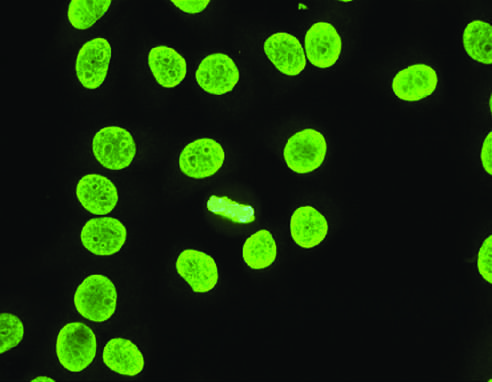what is typical of antibodies reactive with dsdna, nucleosomes, and histones, and is common in sle?
Answer the question using a single word or phrase. Homogeneous or diffuse staining of nuclei 